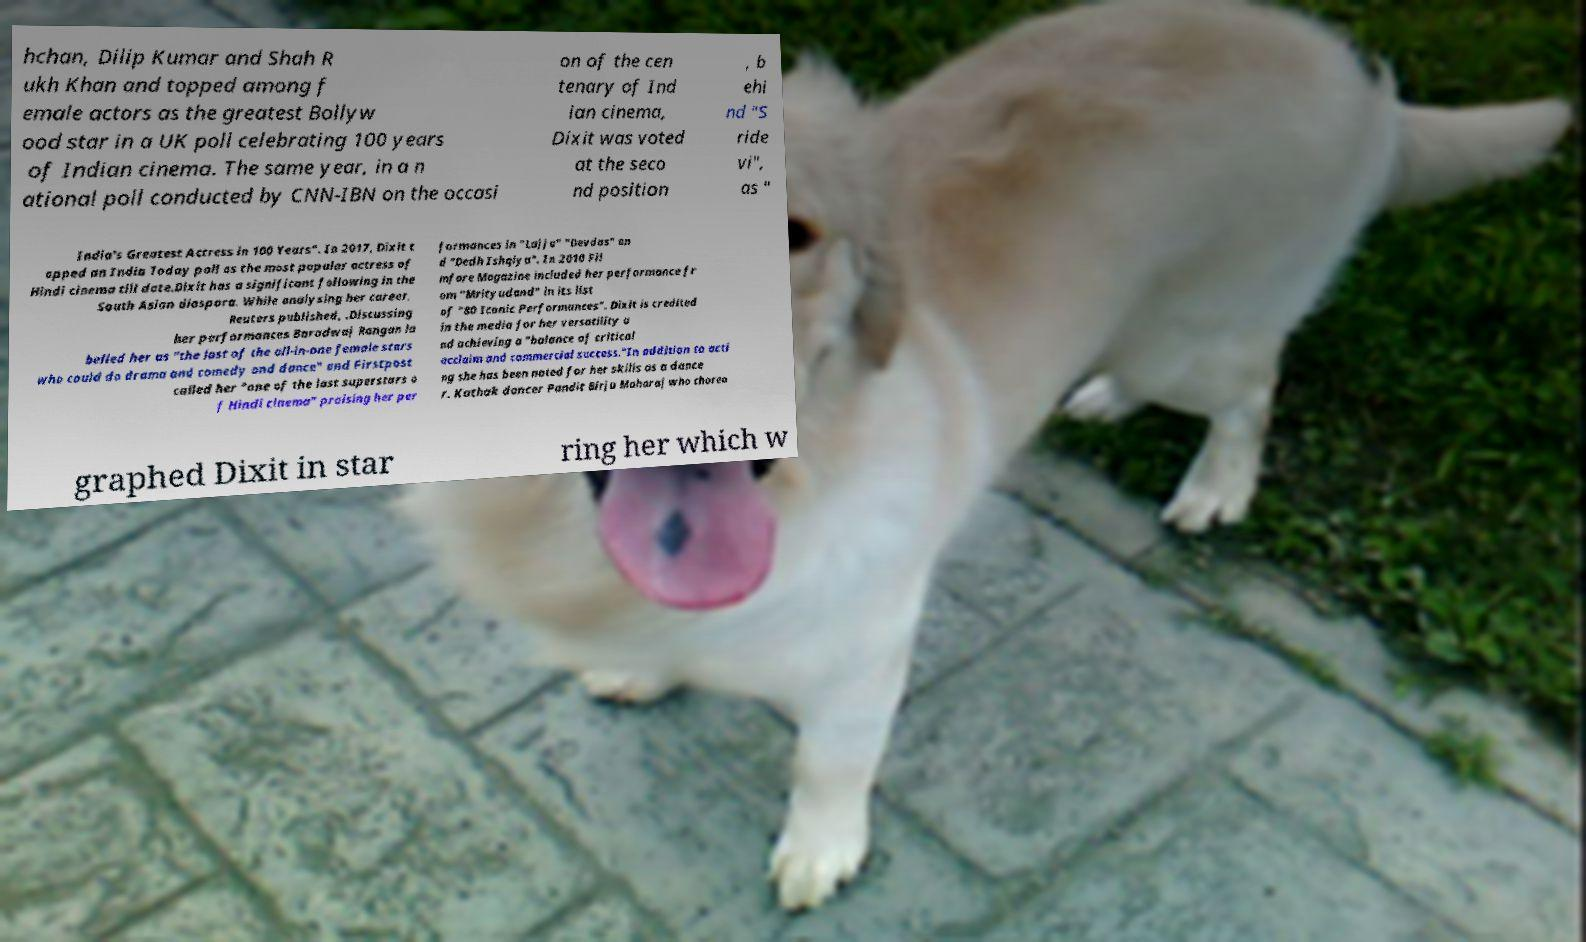I need the written content from this picture converted into text. Can you do that? hchan, Dilip Kumar and Shah R ukh Khan and topped among f emale actors as the greatest Bollyw ood star in a UK poll celebrating 100 years of Indian cinema. The same year, in a n ational poll conducted by CNN-IBN on the occasi on of the cen tenary of Ind ian cinema, Dixit was voted at the seco nd position , b ehi nd "S ride vi", as " India's Greatest Actress in 100 Years". In 2017, Dixit t opped an India Today poll as the most popular actress of Hindi cinema till date.Dixit has a significant following in the South Asian diaspora. While analysing her career, Reuters published, .Discussing her performances Baradwaj Rangan la belled her as "the last of the all-in-one female stars who could do drama and comedy and dance" and Firstpost called her "one of the last superstars o f Hindi cinema" praising her per formances in "Lajja" "Devdas" an d "Dedh Ishqiya". In 2010 Fil mfare Magazine included her performance fr om "Mrityudand" in its list of "80 Iconic Performances". Dixit is credited in the media for her versatility a nd achieving a "balance of critical acclaim and commercial success."In addition to acti ng she has been noted for her skills as a dance r. Kathak dancer Pandit Birju Maharaj who choreo graphed Dixit in star ring her which w 